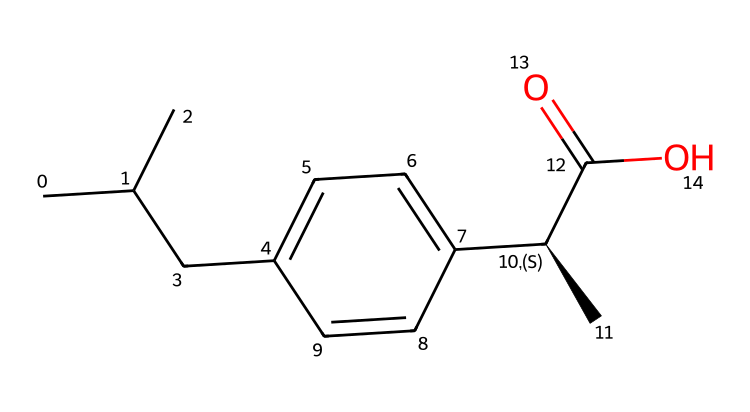How many carbon atoms are in ibuprofen? By examining the SMILES representation, we can count the number of carbon atoms (C) present. Each 'C' in the structure represents a carbon atom, and there are a total of 13 carbon atoms visible in the structure.
Answer: 13 What is the molecular formula of ibuprofen? To derive the molecular formula from the SMILES, we need to count each type of atom. There are 13 carbon atoms, 18 hydrogen atoms, and 2 oxygen atoms, leading to the molecular formula C13H18O2.
Answer: C13H18O2 What is the functional group present in ibuprofen? The presence of the carboxylic acid group (-COOH) is indicated by the part of the structure that includes a carbon atom double-bonded to an oxygen atom and single-bonded to a hydroxyl group (-OH). This is characteristic of carboxylic acids.
Answer: carboxylic acid How many rings are in the ibuprofen structure? Analyzing the molecular structure, we can see only one ring which is the cyclohexane derivative present in the benzene-like component of ibuprofen.
Answer: 1 What type of chemical is ibuprofen classified as? Ibuprofen's structure is indicative of non-steroidal anti-inflammatory drugs (NSAIDs), which are known for their pain-relieving properties. Its composition suggests it acting as an analgesic and anti-inflammatory agent.
Answer: NSAID Is ibuprofen chiral? In the SMILES provided, there is a chiral center indicated by the stereochemistry marked with [C@H]. This carbon atom is attached to four different groups, confirming that ibuprofen is indeed chiral.
Answer: Yes What type of interaction will ibuprofen likely have with pain receptors? Due to its functional groups and molecular makeup, ibuprofen likely undergoes hydrophobic interactions with the pain receptors, leading to effective pain relief.
Answer: hydrophobic interactions 